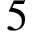<formula> <loc_0><loc_0><loc_500><loc_500>5</formula> 